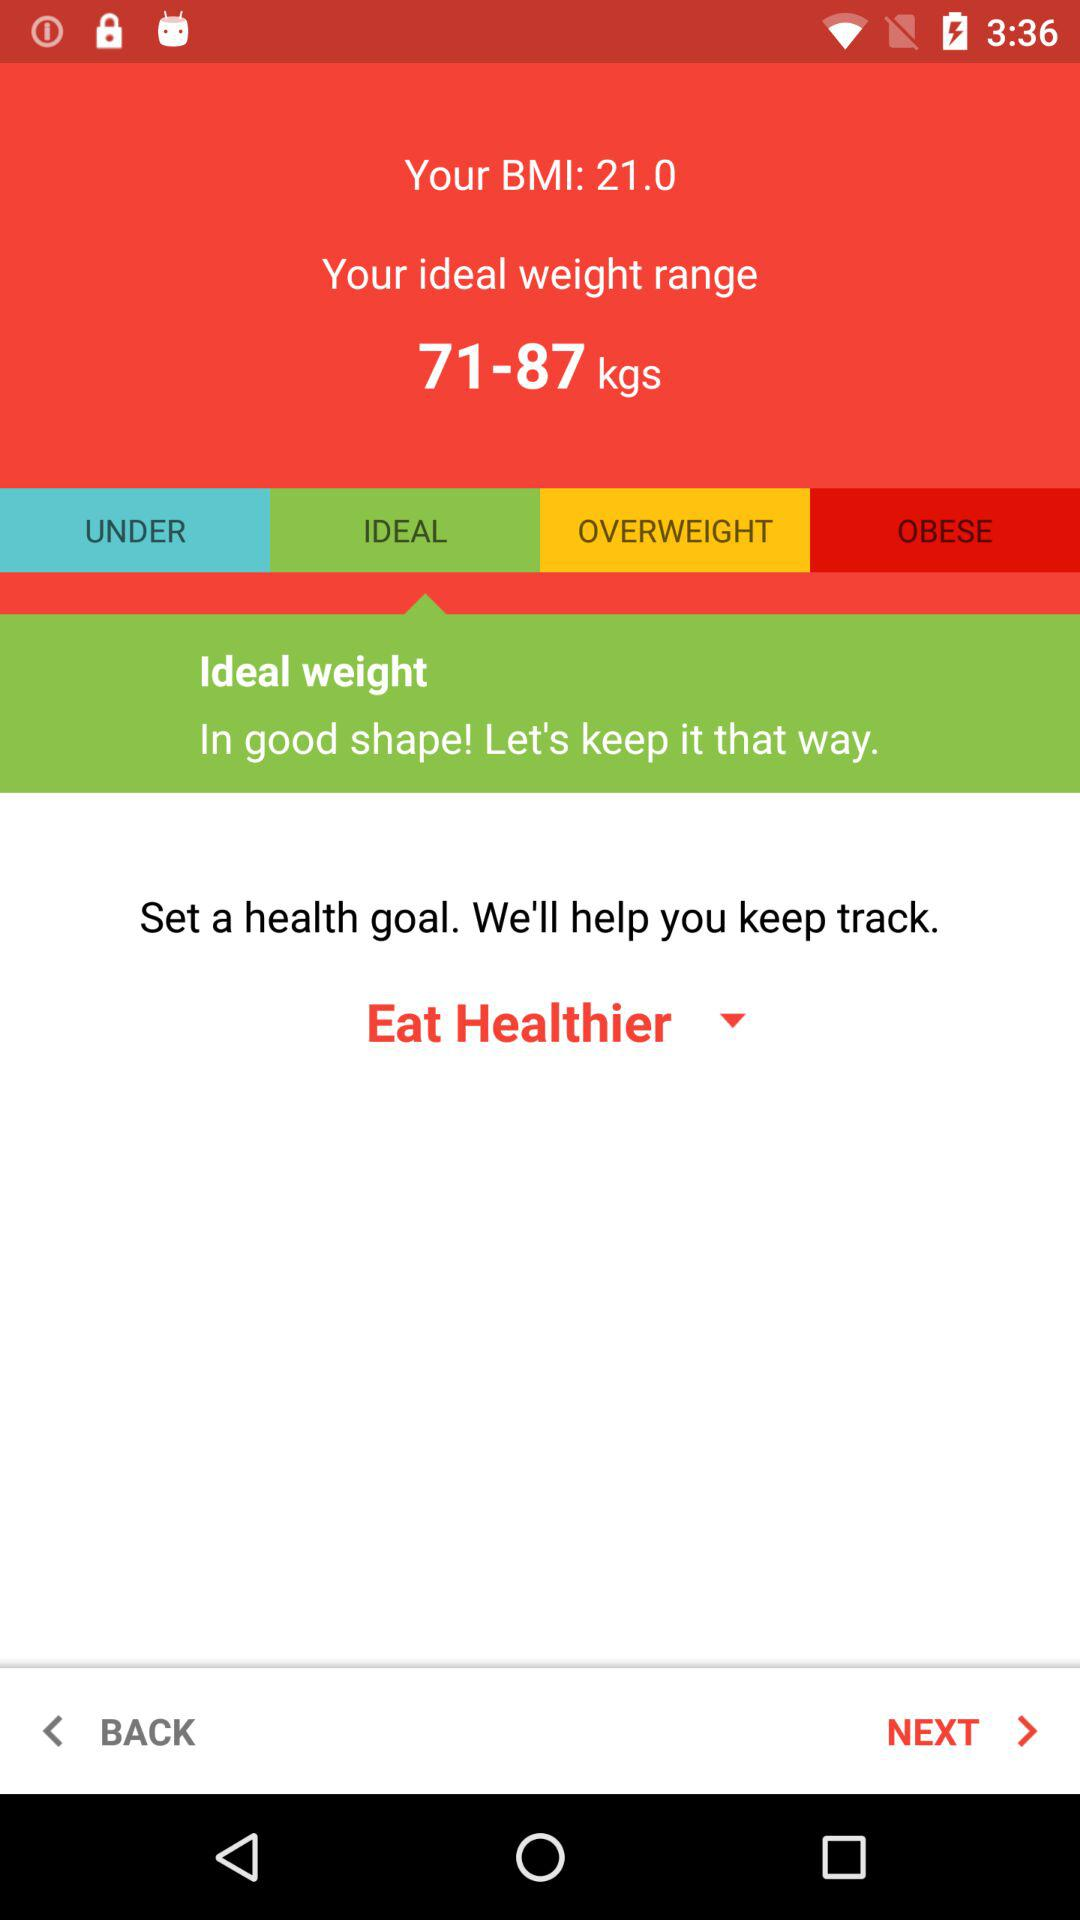How much does the user currently weigh?
When the provided information is insufficient, respond with <no answer>. <no answer> 